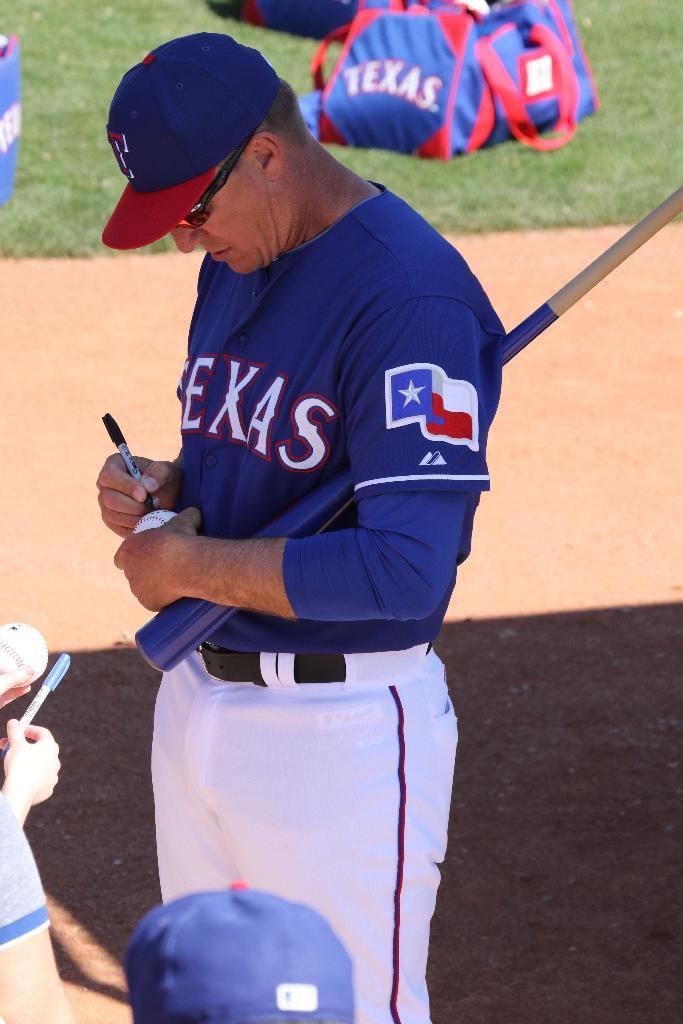<image>
Offer a succinct explanation of the picture presented. A baseball player in a Texas jersey is signing baseballs for fans. 